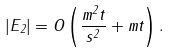Convert formula to latex. <formula><loc_0><loc_0><loc_500><loc_500>| E _ { 2 } | = O \left ( \frac { m ^ { 2 } t } { s ^ { 2 } } + m t \right ) .</formula> 